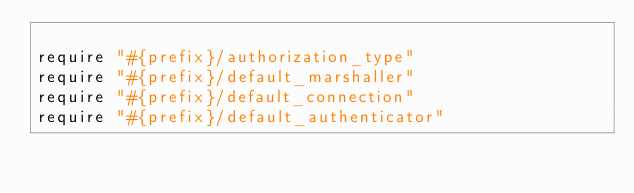Convert code to text. <code><loc_0><loc_0><loc_500><loc_500><_Ruby_>
require "#{prefix}/authorization_type"
require "#{prefix}/default_marshaller"
require "#{prefix}/default_connection"
require "#{prefix}/default_authenticator"
</code> 